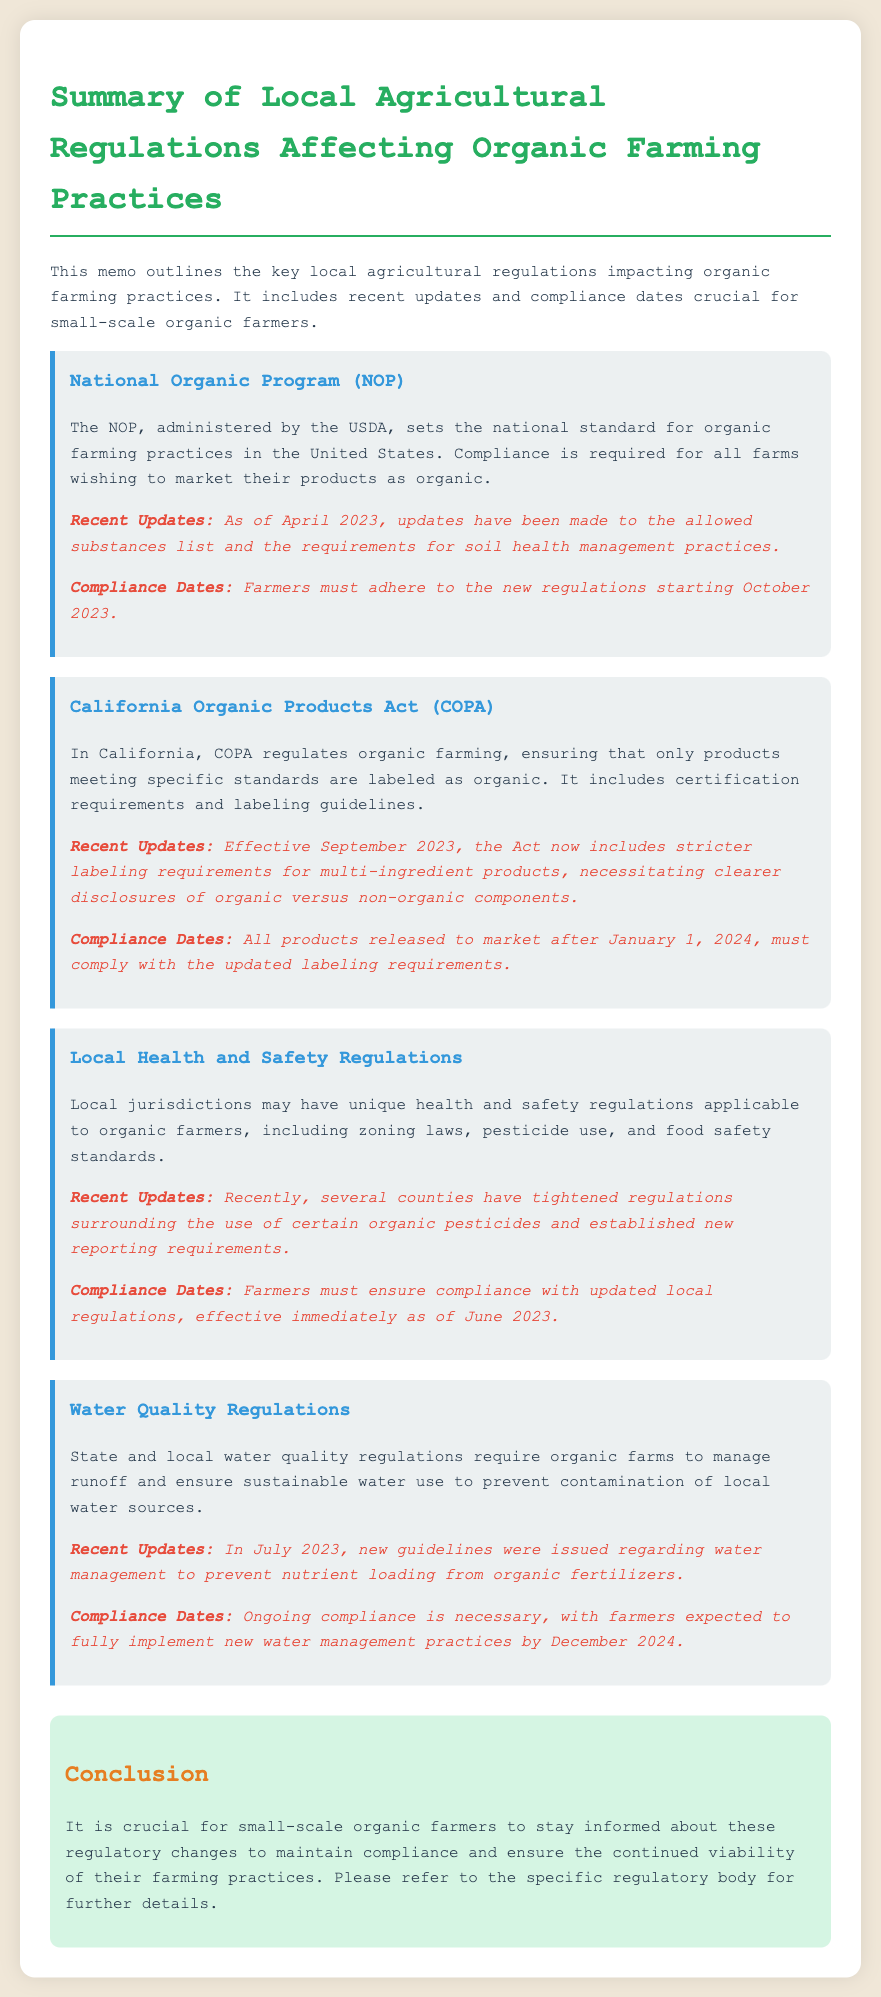What is the governing body for the National Organic Program? The governing body for the National Organic Program is the USDA.
Answer: USDA When did the recent updates to the NOP take effect? The recent updates to the NOP took effect in April 2023.
Answer: April 2023 What is the new compliance date for the California Organic Products Act updates? The new compliance date for the California Organic Products Act updates is January 1, 2024.
Answer: January 1, 2024 What new reporting requirements were introduced in local health and safety regulations? New reporting requirements were introduced surrounding the use of certain organic pesticides.
Answer: Organic pesticides By when must farmers implement new water management practices? Farmers must implement new water management practices by December 2024.
Answer: December 2024 Which act includes stricter labeling requirements for multi-ingredient products? The act that includes stricter labeling requirements for multi-ingredient products is COPA.
Answer: COPA What is the focus of the water quality regulations? The focus of the water quality regulations is to manage runoff and ensure sustainable water use.
Answer: Runoff management What is the main purpose of the memo? The main purpose of the memo is to outline local agricultural regulations impacting organic farming practices.
Answer: Outline regulations 